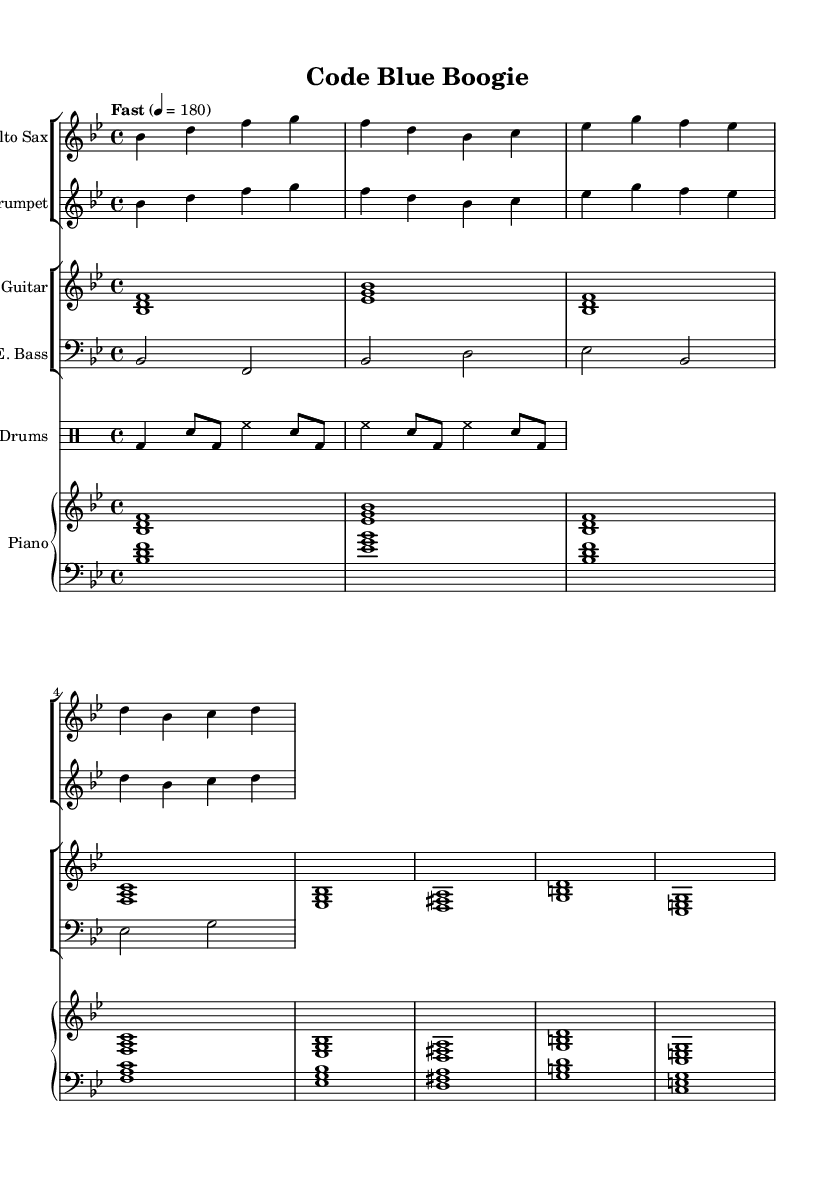What is the key signature of this music? The key signature is indicated at the beginning of the music. In this case, there are two flats (B and E), which corresponds to B flat major.
Answer: B flat major What is the time signature of this music? The time signature is shown at the beginning of the music, next to the key signature. It is 4 over 4, which is a common time signature indicating four beats in a measure.
Answer: 4/4 What is the tempo marking for this composition? The tempo for the piece is written above the staff, stating "Fast" with a metronome marking of 180, indicating a brisk pace.
Answer: Fast, 180 Which instruments are featured in this score? The instruments are listed at the beginning of each staff. The featured instruments are Alto Sax, Trumpet, Electric Guitar, Electric Bass, Drums, and Piano.
Answer: Alto Sax, Trumpet, Electric Guitar, Electric Bass, Drums, Piano How many bars are in the first line of music? By counting the measures across the first line, we see there are four bars or measures in total. Each measure contains the same number of beats as indicated by the time signature.
Answer: 4 Which instrument has the lowest pitch range? The Electric Bass, shown in bass clef, typically plays lower pitches compared to other instruments, making it the lowest in pitch range among those listed.
Answer: Electric Bass What style is this composition intended to reflect? The title "Code Blue Boogie" suggests it is a jazz fusion piece that incorporates upbeat elements while possibly capturing the essence of emergency response scenarios, merging music with thematic inspiration.
Answer: Jazz fusion 